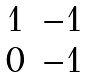<formula> <loc_0><loc_0><loc_500><loc_500>\begin{matrix} 1 & - 1 \\ 0 & - 1 \end{matrix}</formula> 